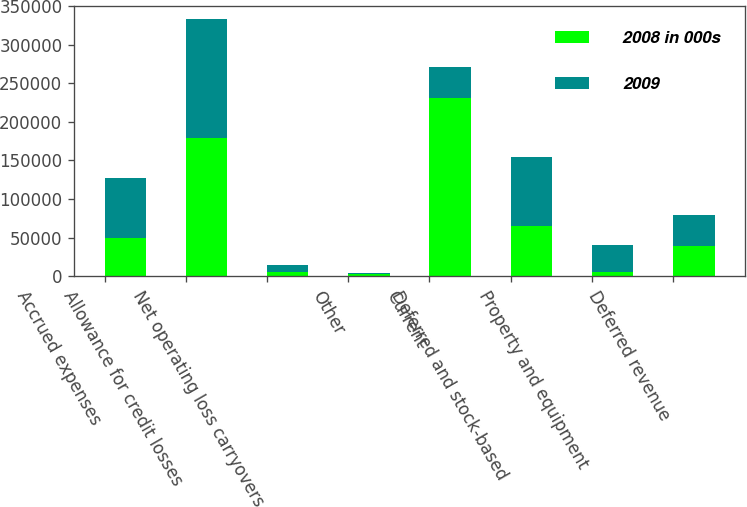Convert chart. <chart><loc_0><loc_0><loc_500><loc_500><stacked_bar_chart><ecel><fcel>Accrued expenses<fcel>Allowance for credit losses<fcel>Net operating loss carryovers<fcel>Other<fcel>Current<fcel>Deferred and stock-based<fcel>Property and equipment<fcel>Deferred revenue<nl><fcel>2008 in 000s<fcel>49239<fcel>179508<fcel>5495<fcel>2119<fcel>231588<fcel>65493<fcel>5743<fcel>39489<nl><fcel>2009<fcel>78618<fcel>154320<fcel>8771<fcel>2523<fcel>40339<fcel>88797<fcel>34180<fcel>40339<nl></chart> 